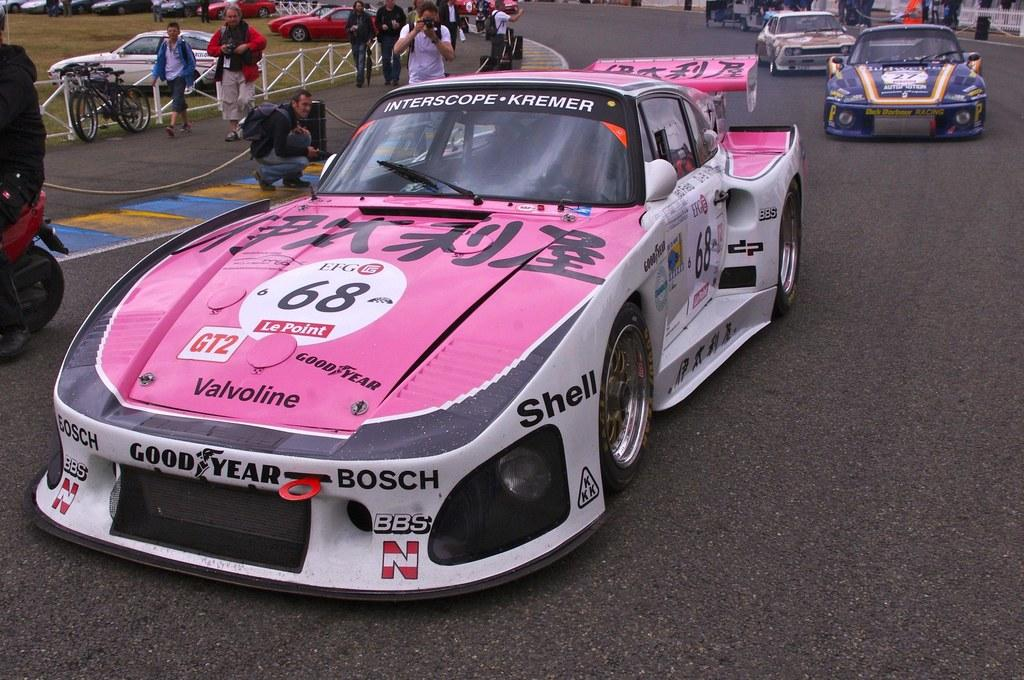What can be seen in the image that moves on roads or streets? There are vehicles in the image that move on roads or streets. What are the people in the image doing? The people in the image are walking. Can you describe the person holding an object in front of the image? A person is holding a camera in front of the image. What type of nail is being used by the person holding a camera in the image? There is no nail present in the image; the person is holding a camera. How does the potato play a role in the image? There is no potato present in the image, so it cannot play any role. 